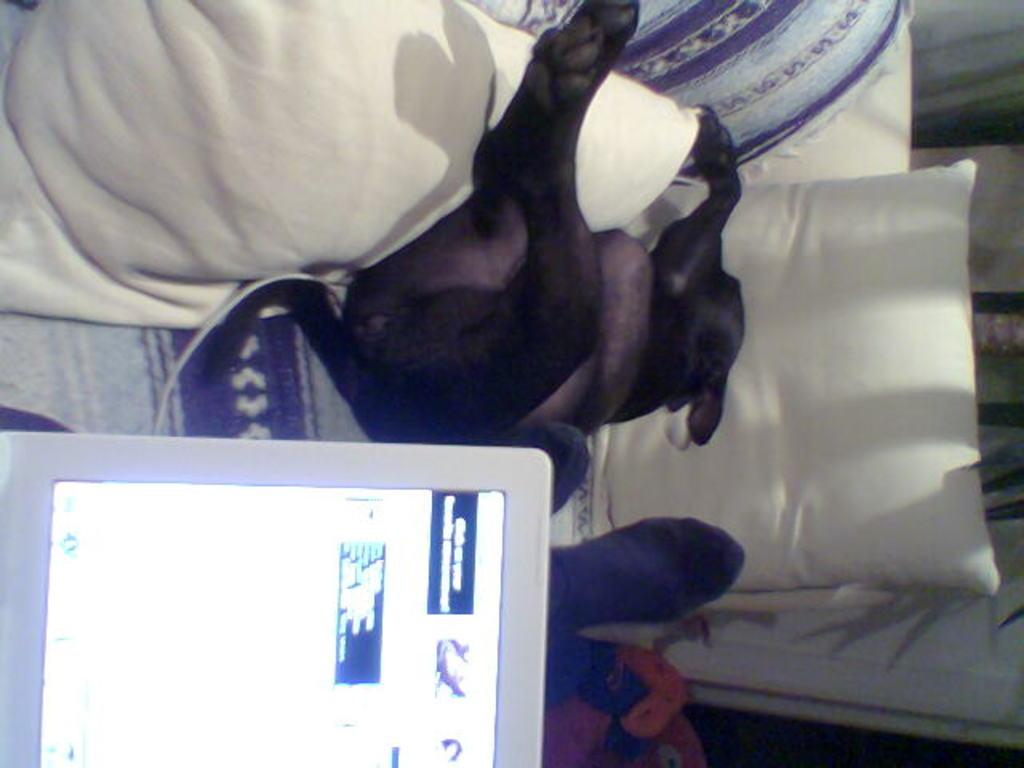What type of objects can be seen on the couch in the image? There are pillows, a dog, and a screen on the couch in the image. Can you describe the dog in the image? The image features a dog, but no specific details about the dog's breed, color, or size are provided. What is the screen on the couch used for? The purpose of the screen on the couch is not specified in the image. Are there any other objects or furniture visible in the image? The facts provided only mention the presence of pillows, a dog, and a screen on the couch. What type of curtain is hanging over the dog in the image? There is no curtain present in the image; it only features pillows, a dog, and a screen on the couch. Is the veil used to cover the dog or the screen in the image? There is no veil present in the image. 